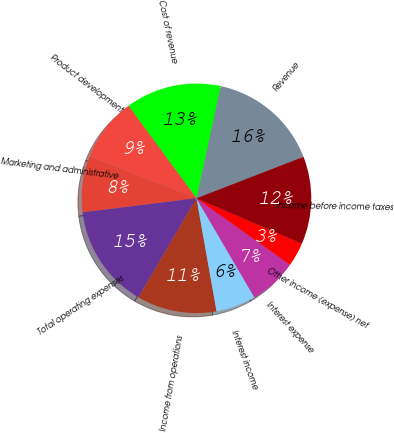<chart> <loc_0><loc_0><loc_500><loc_500><pie_chart><fcel>Revenue<fcel>Cost of revenue<fcel>Product development<fcel>Marketing and administrative<fcel>Total operating expenses<fcel>Income from operations<fcel>Interest income<fcel>Interest expense<fcel>Other income (expense) net<fcel>Income before income taxes<nl><fcel>15.73%<fcel>13.48%<fcel>8.99%<fcel>7.87%<fcel>14.61%<fcel>11.24%<fcel>5.62%<fcel>6.74%<fcel>3.37%<fcel>12.36%<nl></chart> 